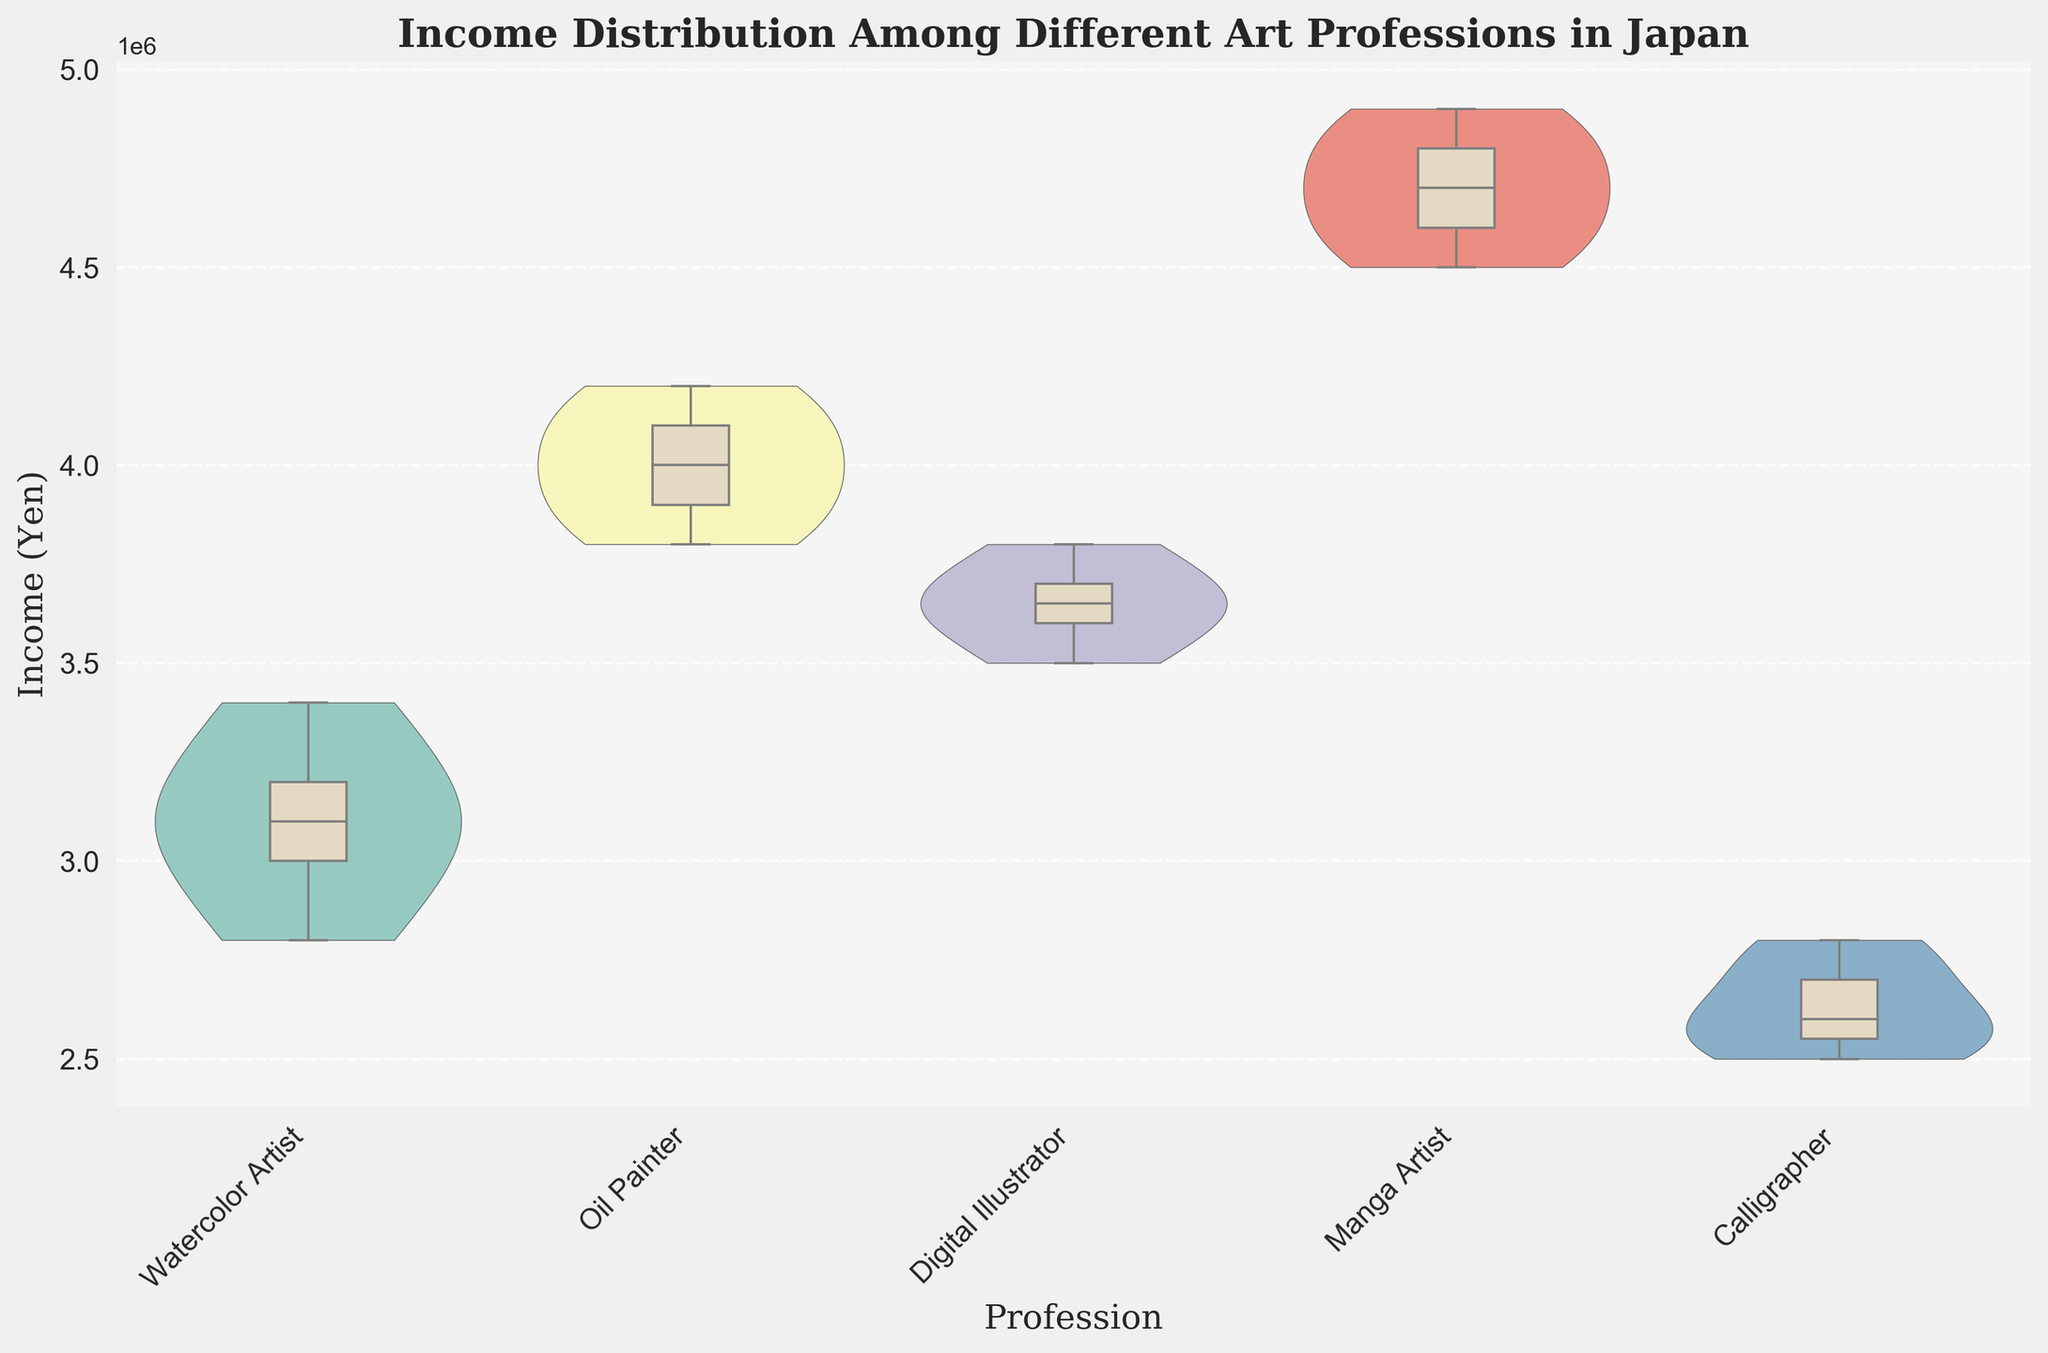What is the title of the figure? The title of the figure is the text located at the top of the plot that describes the main idea or purpose of the visualization.
Answer: "Income Distribution Among Different Art Professions in Japan" Which profession has the widest income distribution? The widest income distribution can be observed by looking at the violin plot widths. The Manga Artist profession has the widest distribution shown by the widest violin plot.
Answer: Manga Artist What is the median income for Oil Painters? The median income is represented by the line inside the box of the box plot. For Oil Painters, the median income line is at 4000000 yen.
Answer: 4000000 yen Which profession has the lowest median income? By comparing the lines inside the box plots, the lowest median income is for Calligraphers.
Answer: Calligraphers What is the highest income recorded for Digital Illustrators? The highest point within the whiskers of the box plot for Digital Illustrators represents the highest income, which is 3800000 yen.
Answer: 3800000 yen Compare the income range of Watercolor Artists and Calligraphers. Which is larger? To compare ranges, look at the span from the bottom to the top of the whiskers. Watercolor Artists range from 2800000 to 3400000 yen (600000 yen), while Calligraphers range from 2500000 to 2800000 yen (300000 yen). Hence, Watercolor Artists have a larger range.
Answer: Watercolor Artists How does the median income of Manga Artists compare to that of Digital Illustrators? The line inside the box plot shows the median income. Manga Artists have a median income around 4700000 yen, while Digital Illustrators have about 3650000 yen. Thus, Manga Artists have a higher median income.
Answer: Manga Artists Which two professions have the closest median incomes? By comparing the lines inside the box plots of all professions, Watercolor Artists and Oil Painters have the closest median incomes, both around 3100000 yen and 4000000 yen respectively.
Answer: Watercolor Artists and Oil Painters Are there any professions with outliers in their income distribution? Outliers would typically be represented by individual points outside the whiskers of the box plot. In this plot, there are no outliers shown as specified in the figure.
Answer: No What can you infer about the income stability of Calligraphers compared to Oil Painters? Income stability can be inferred by looking at the width and height of violin plots and box plots. Calligraphers show a narrower income distribution with a smaller range (2500000 to 2800000 yen), while Oil Painters have a wider distribution (3800000 to 4200000 yen), indicating more stable incomes for Calligraphers.
Answer: Calligraphers have more stable incomes 